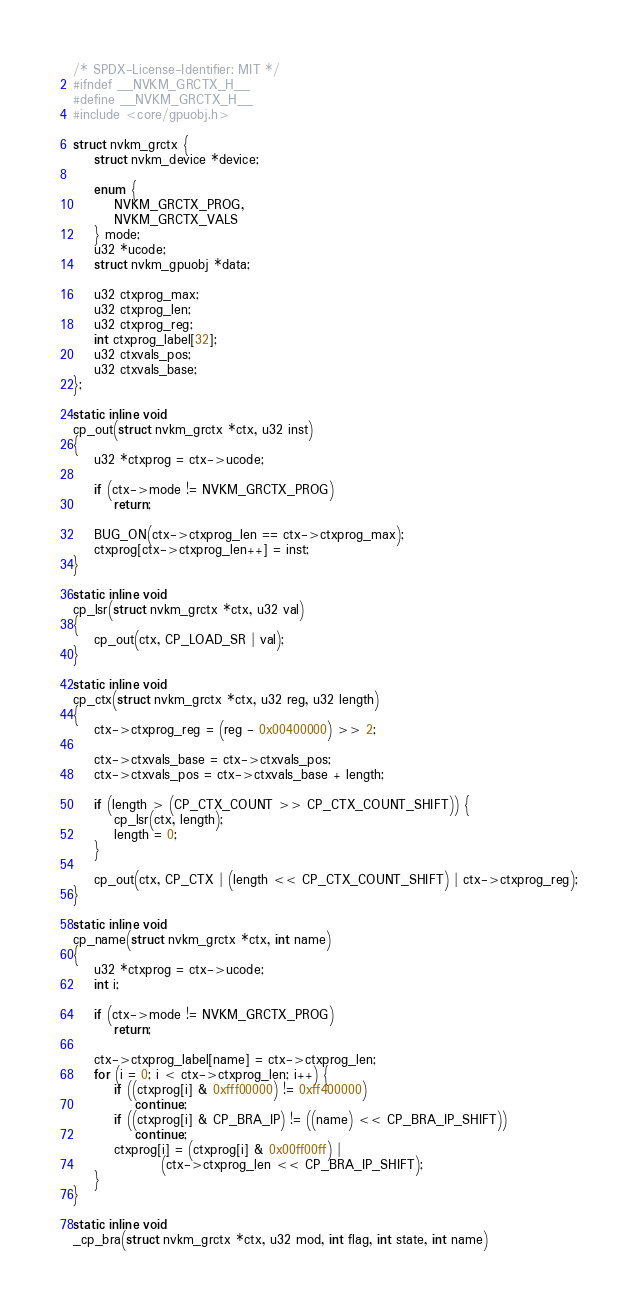<code> <loc_0><loc_0><loc_500><loc_500><_C_>/* SPDX-License-Identifier: MIT */
#ifndef __NVKM_GRCTX_H__
#define __NVKM_GRCTX_H__
#include <core/gpuobj.h>

struct nvkm_grctx {
	struct nvkm_device *device;

	enum {
		NVKM_GRCTX_PROG,
		NVKM_GRCTX_VALS
	} mode;
	u32 *ucode;
	struct nvkm_gpuobj *data;

	u32 ctxprog_max;
	u32 ctxprog_len;
	u32 ctxprog_reg;
	int ctxprog_label[32];
	u32 ctxvals_pos;
	u32 ctxvals_base;
};

static inline void
cp_out(struct nvkm_grctx *ctx, u32 inst)
{
	u32 *ctxprog = ctx->ucode;

	if (ctx->mode != NVKM_GRCTX_PROG)
		return;

	BUG_ON(ctx->ctxprog_len == ctx->ctxprog_max);
	ctxprog[ctx->ctxprog_len++] = inst;
}

static inline void
cp_lsr(struct nvkm_grctx *ctx, u32 val)
{
	cp_out(ctx, CP_LOAD_SR | val);
}

static inline void
cp_ctx(struct nvkm_grctx *ctx, u32 reg, u32 length)
{
	ctx->ctxprog_reg = (reg - 0x00400000) >> 2;

	ctx->ctxvals_base = ctx->ctxvals_pos;
	ctx->ctxvals_pos = ctx->ctxvals_base + length;

	if (length > (CP_CTX_COUNT >> CP_CTX_COUNT_SHIFT)) {
		cp_lsr(ctx, length);
		length = 0;
	}

	cp_out(ctx, CP_CTX | (length << CP_CTX_COUNT_SHIFT) | ctx->ctxprog_reg);
}

static inline void
cp_name(struct nvkm_grctx *ctx, int name)
{
	u32 *ctxprog = ctx->ucode;
	int i;

	if (ctx->mode != NVKM_GRCTX_PROG)
		return;

	ctx->ctxprog_label[name] = ctx->ctxprog_len;
	for (i = 0; i < ctx->ctxprog_len; i++) {
		if ((ctxprog[i] & 0xfff00000) != 0xff400000)
			continue;
		if ((ctxprog[i] & CP_BRA_IP) != ((name) << CP_BRA_IP_SHIFT))
			continue;
		ctxprog[i] = (ctxprog[i] & 0x00ff00ff) |
			     (ctx->ctxprog_len << CP_BRA_IP_SHIFT);
	}
}

static inline void
_cp_bra(struct nvkm_grctx *ctx, u32 mod, int flag, int state, int name)</code> 